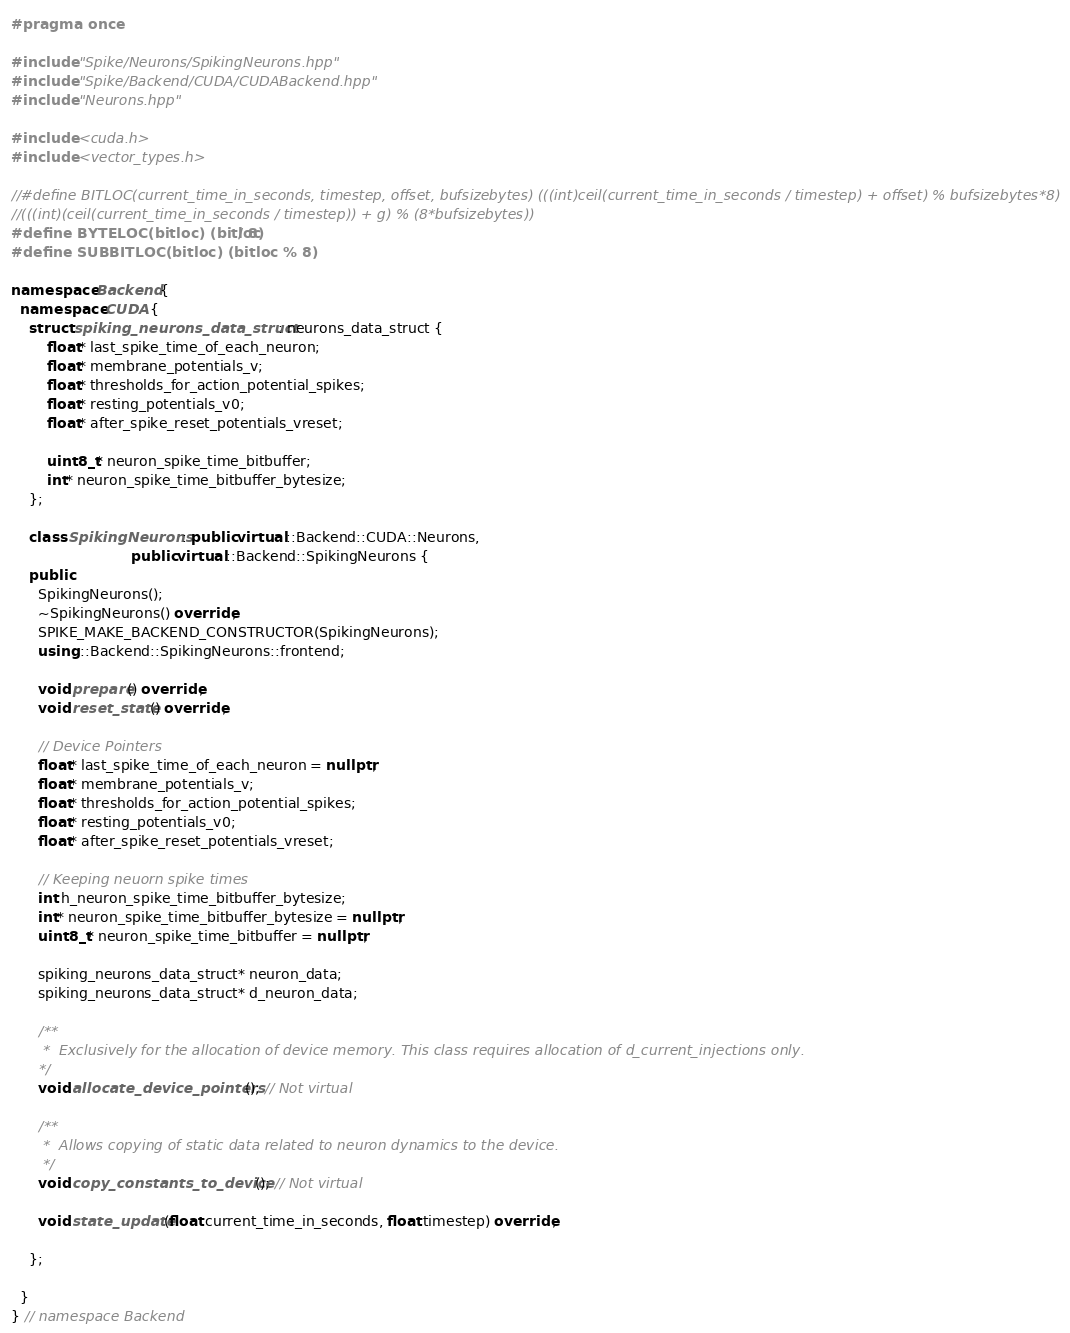Convert code to text. <code><loc_0><loc_0><loc_500><loc_500><_C++_>#pragma once

#include "Spike/Neurons/SpikingNeurons.hpp"
#include "Spike/Backend/CUDA/CUDABackend.hpp"
#include "Neurons.hpp"

#include <cuda.h>
#include <vector_types.h>

//#define BITLOC(current_time_in_seconds, timestep, offset, bufsizebytes) (((int)ceil(current_time_in_seconds / timestep) + offset) % bufsizebytes*8)
//(((int)(ceil(current_time_in_seconds / timestep)) + g) % (8*bufsizebytes))
#define BYTELOC(bitloc) (bitloc / 8)
#define SUBBITLOC(bitloc) (bitloc % 8)

namespace Backend {
  namespace CUDA {
    struct spiking_neurons_data_struct : neurons_data_struct {
        float* last_spike_time_of_each_neuron;
        float* membrane_potentials_v; 
        float* thresholds_for_action_potential_spikes;
        float* resting_potentials_v0;
        float* after_spike_reset_potentials_vreset;

        uint8_t* neuron_spike_time_bitbuffer;
        int* neuron_spike_time_bitbuffer_bytesize;
    };

    class SpikingNeurons : public virtual ::Backend::CUDA::Neurons,
                           public virtual ::Backend::SpikingNeurons {
    public:
      SpikingNeurons();
      ~SpikingNeurons() override;
      SPIKE_MAKE_BACKEND_CONSTRUCTOR(SpikingNeurons);
      using ::Backend::SpikingNeurons::frontend;

      void prepare() override;
      void reset_state() override;

      // Device Pointers
      float* last_spike_time_of_each_neuron = nullptr;
      float* membrane_potentials_v;
      float* thresholds_for_action_potential_spikes;
      float* resting_potentials_v0;
      float* after_spike_reset_potentials_vreset;

      // Keeping neuorn spike times
      int h_neuron_spike_time_bitbuffer_bytesize;
      int* neuron_spike_time_bitbuffer_bytesize = nullptr;
      uint8_t* neuron_spike_time_bitbuffer = nullptr;

      spiking_neurons_data_struct* neuron_data;
      spiking_neurons_data_struct* d_neuron_data;

      /**  
       *  Exclusively for the allocation of device memory. This class requires allocation of d_current_injections only.
      */
      void allocate_device_pointers(); // Not virtual

      /**  
       *  Allows copying of static data related to neuron dynamics to the device.
       */
      void copy_constants_to_device(); // Not virtual

      void state_update(float current_time_in_seconds, float timestep) override;
      
    };

  }
} // namespace Backend
</code> 